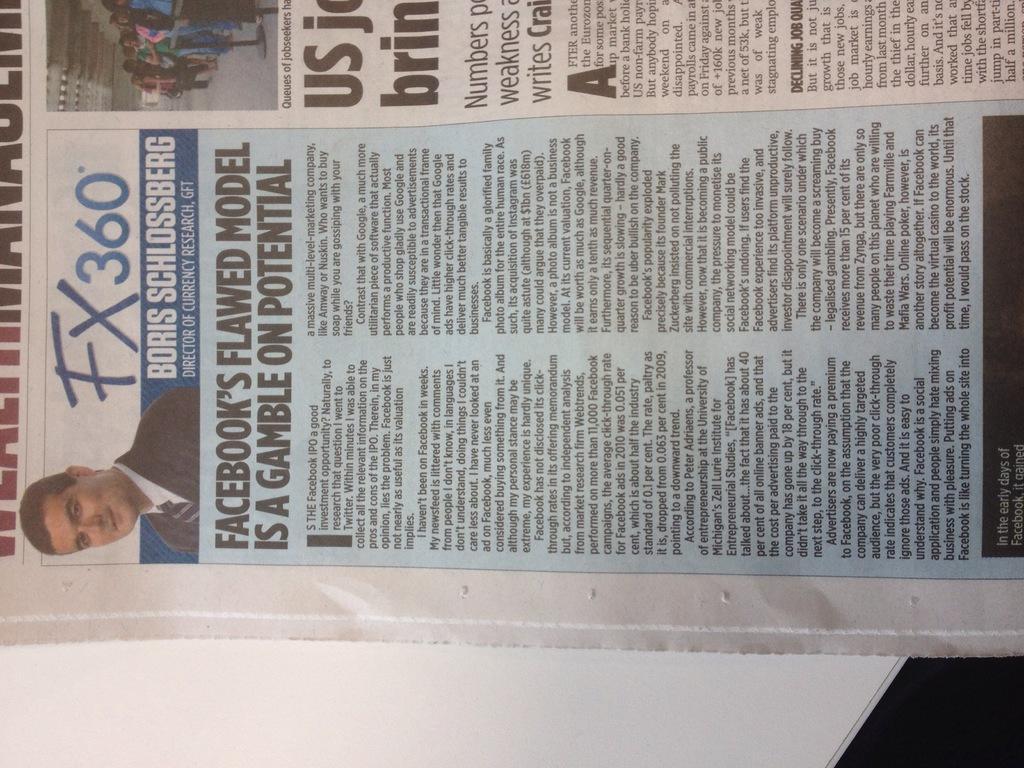In one or two sentences, can you explain what this image depicts? In the image we can see there is a newspaper kept on the table. There is matter written on it and there is a person in the formal suit on the newspaper. It's written ¨FX 360¨. 